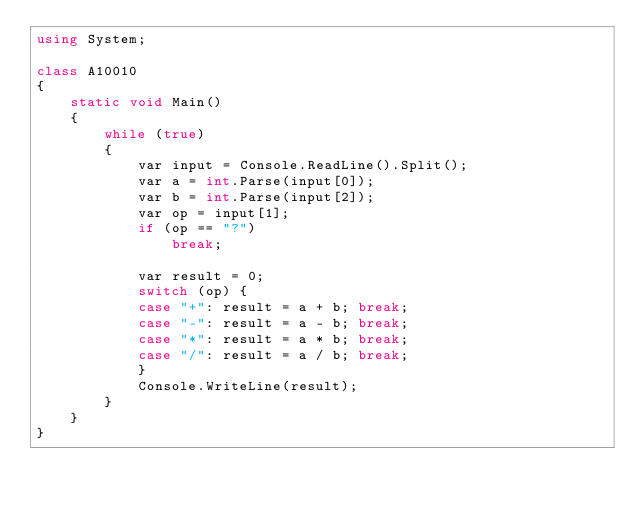Convert code to text. <code><loc_0><loc_0><loc_500><loc_500><_C#_>using System;

class A10010
{
	static void Main()
	{
		while (true)
		{
			var input = Console.ReadLine().Split();
			var a = int.Parse(input[0]);
			var b = int.Parse(input[2]);
			var op = input[1];
			if (op == "?")
				break;

			var result = 0;
			switch (op) {
			case "+": result = a + b; break;
			case "-": result = a - b; break;
			case "*": result = a * b; break;
			case "/": result = a / b; break;
			}
			Console.WriteLine(result);
		}
	}
}</code> 